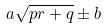Convert formula to latex. <formula><loc_0><loc_0><loc_500><loc_500>a \sqrt { p r + q } \pm b</formula> 